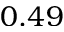<formula> <loc_0><loc_0><loc_500><loc_500>0 . 4 9</formula> 